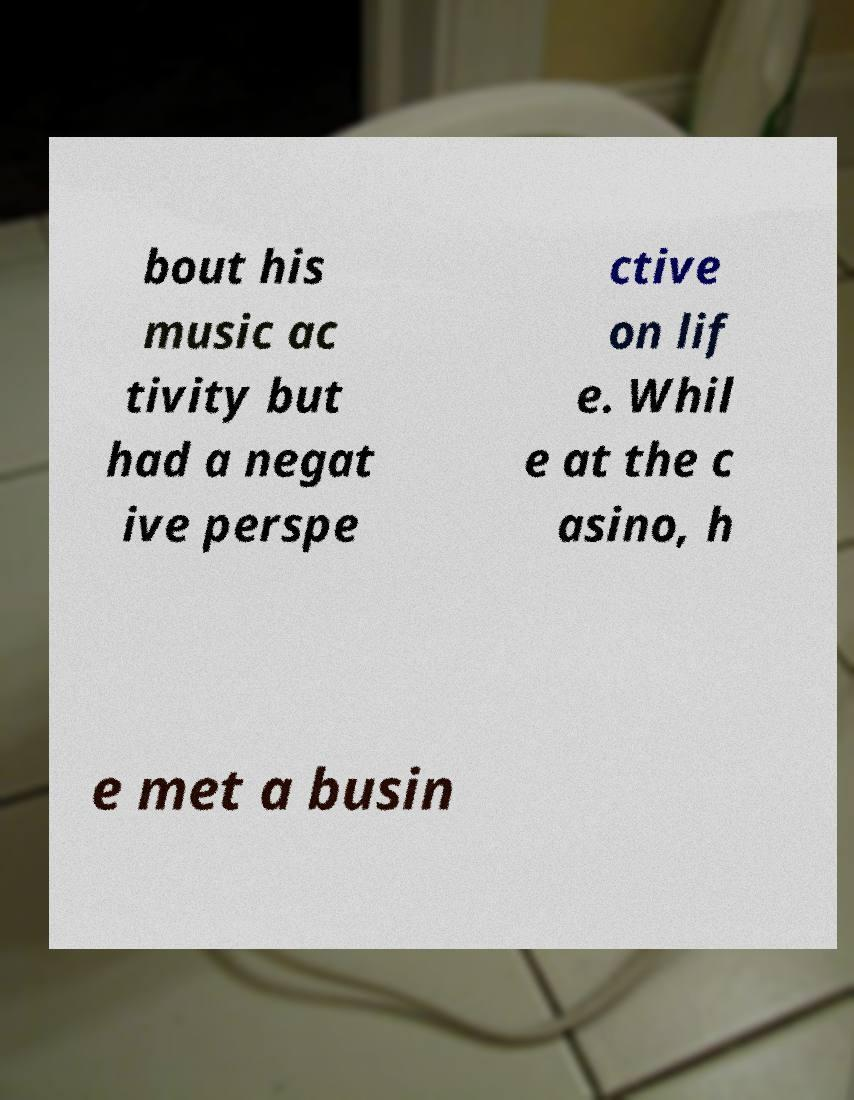Could you assist in decoding the text presented in this image and type it out clearly? bout his music ac tivity but had a negat ive perspe ctive on lif e. Whil e at the c asino, h e met a busin 